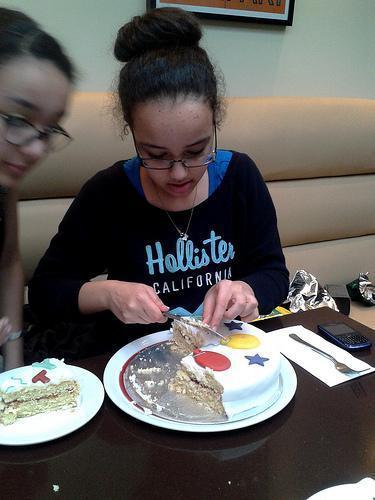How many people are in the picture?
Give a very brief answer. 2. 